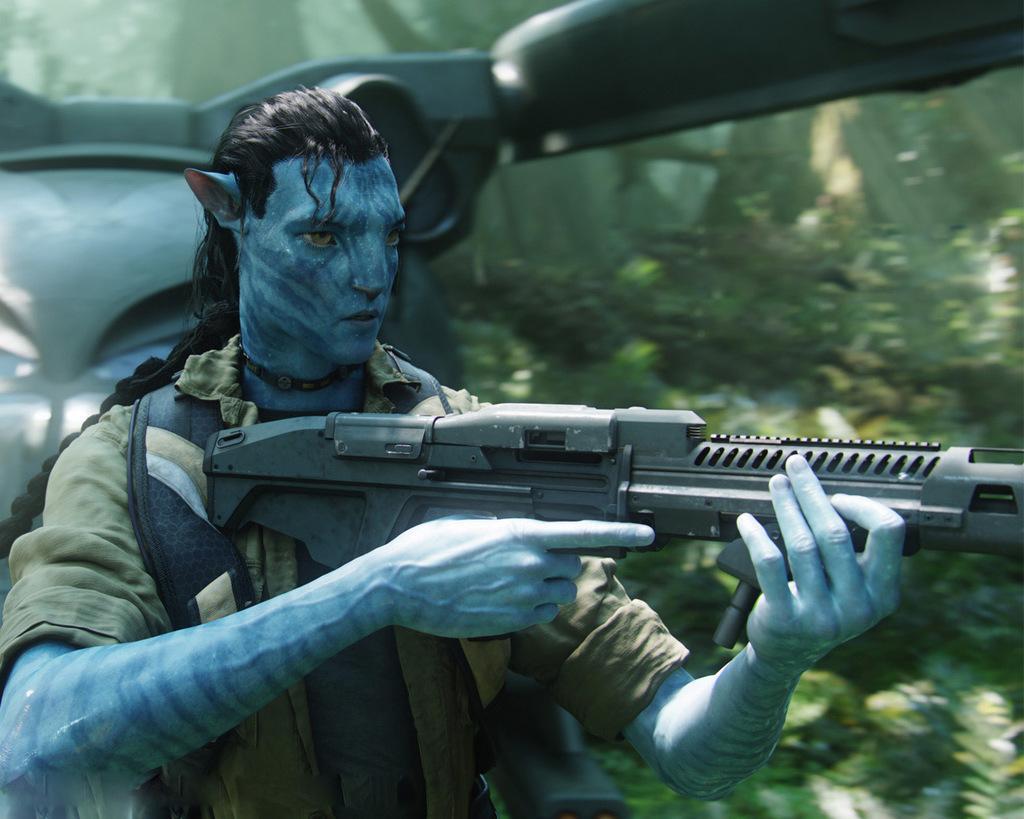Please provide a concise description of this image. In the image a person is standing and holding a weapon. Behind him there is a vehicle and there are some trees. 